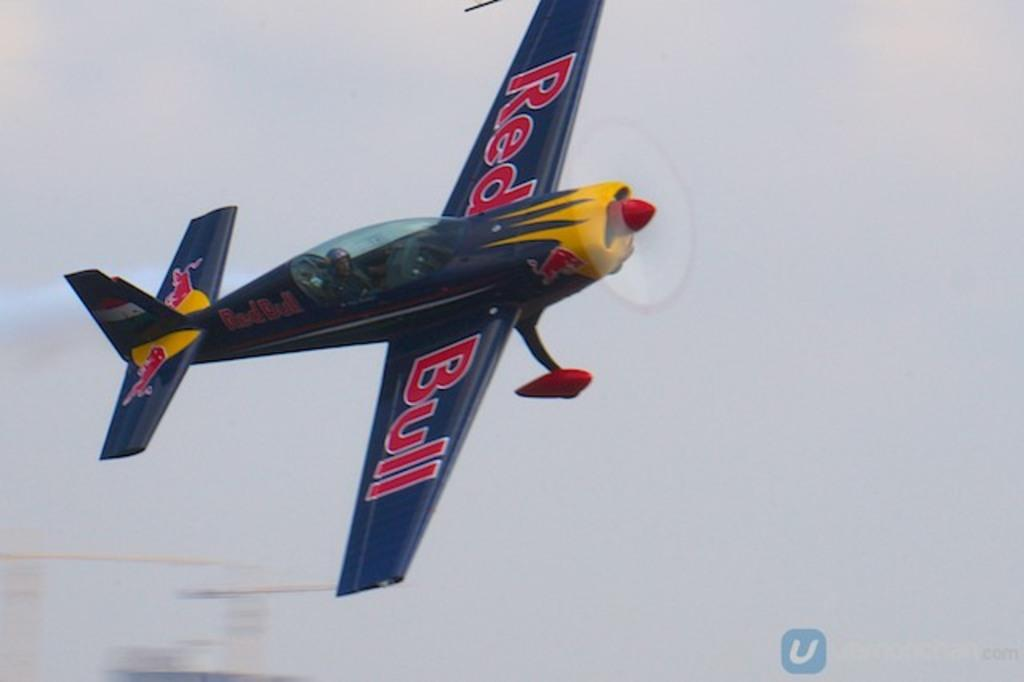What type of aircraft is in the picture? There is a Red Bull Jet in the picture. What is the jet doing in the image? The jet is flying in the sky. What colors can be seen on the jet? The jet has blue, red, and yellow colors. Who is inside the jet? There is a pilot inside the jet. What is the pilot wearing for safety? The pilot is wearing a helmet. What type of shirt is the toy wearing in the image? There is no toy or shirt present in the image; it features a Red Bull Jet flying in the sky with a pilot inside. 